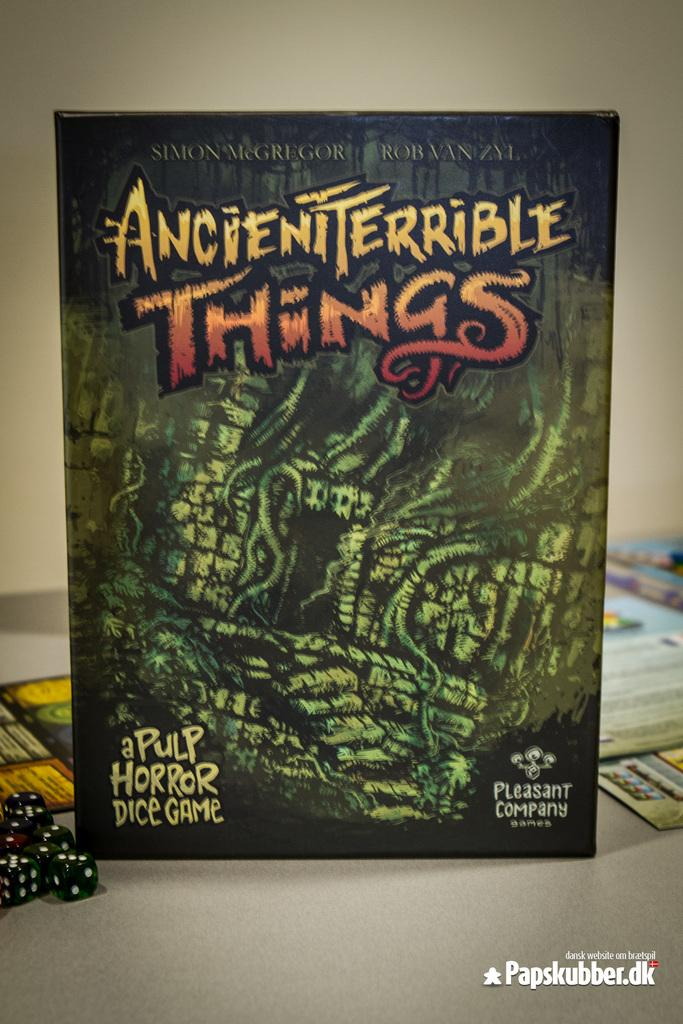<image>
Render a clear and concise summary of the photo. Game titled "Ancient Terrible Things" on top of a table. 